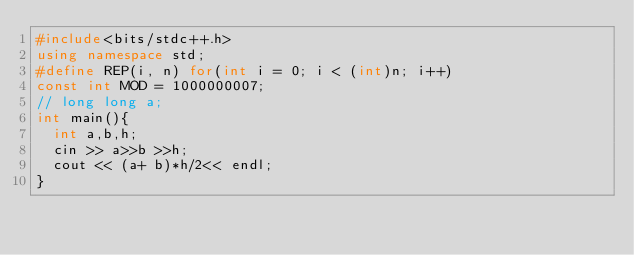Convert code to text. <code><loc_0><loc_0><loc_500><loc_500><_C++_>#include<bits/stdc++.h>
using namespace std;
#define REP(i, n) for(int i = 0; i < (int)n; i++)
const int MOD = 1000000007;
// long long a;
int main(){
  int a,b,h;
  cin >> a>>b >>h;
  cout << (a+ b)*h/2<< endl;
}
</code> 